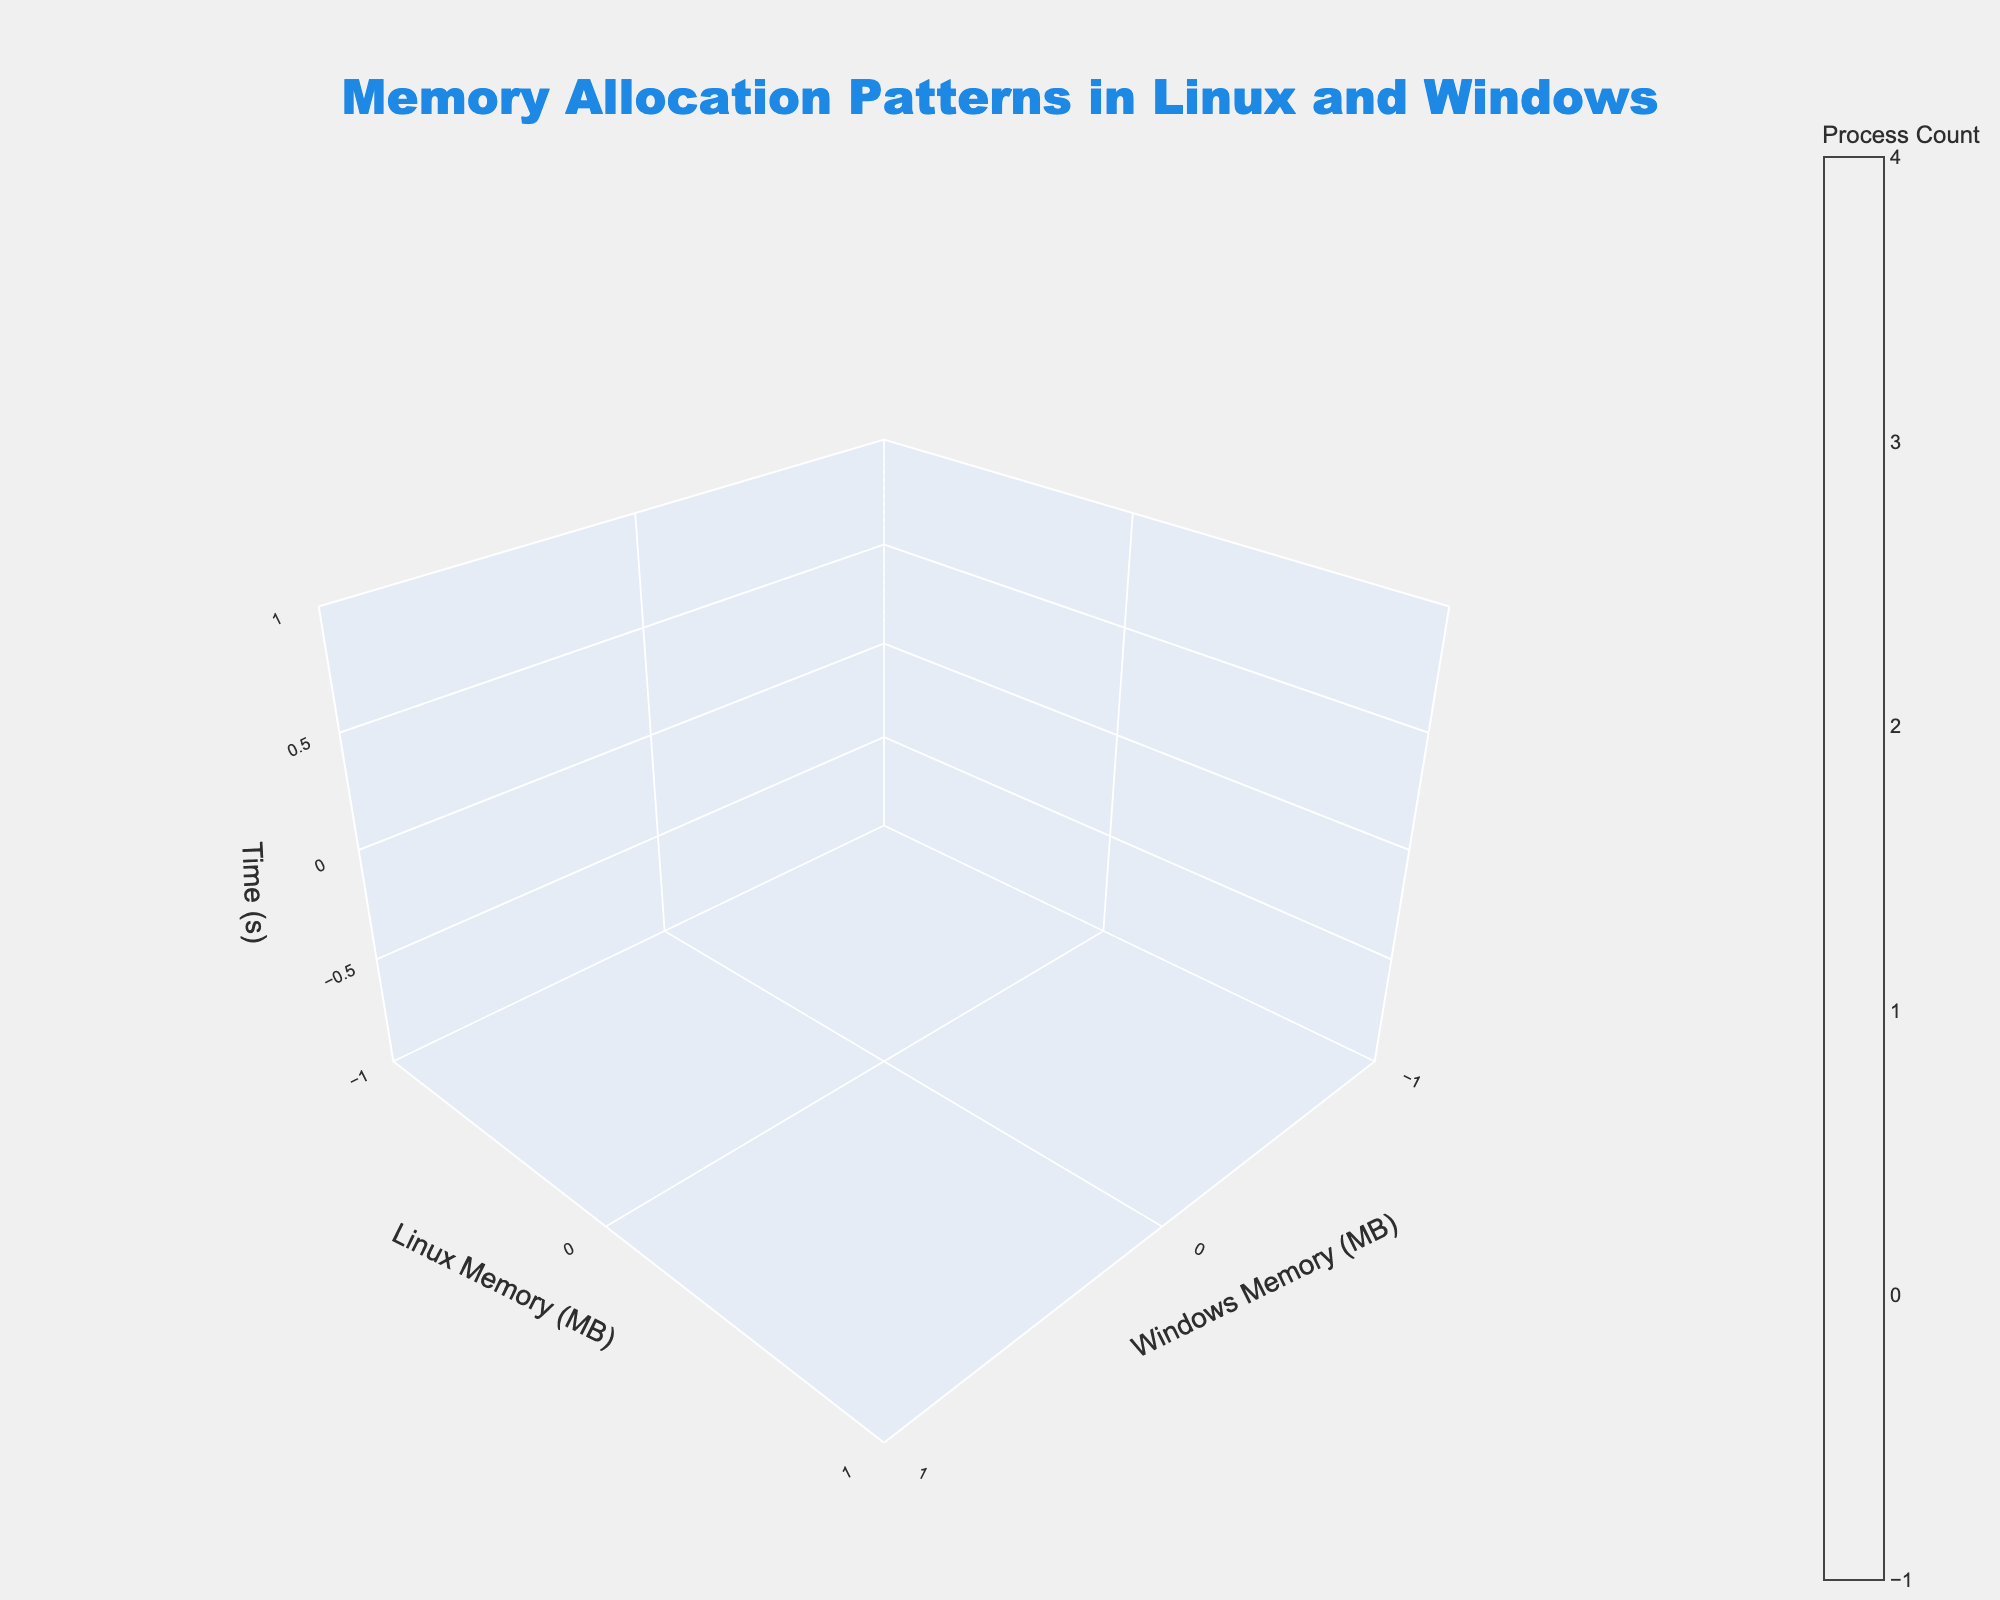What's the title of the 3D volume plot? The title is positioned prominently at the top of the plot.
Answer: Memory Allocation Patterns in Linux and Windows What do the axes represent? The labels on the axes indicate their meaning: the X-axis represents Windows Memory (MB), the Y-axis represents Linux Memory (MB), and the Z-axis represents Time (seconds).
Answer: Windows Memory (MB), Linux Memory (MB), Time (s) How many process counts are represented in the plot at the 0 second mark? By looking at the lowest point in the Z-axis (Time (s) = 0) and mapping to the color scale, we can see the process count value.
Answer: 10 Which memory allocation reaches 2048 MB first, Linux or Windows? Trace both Linux and Windows memory allocations from the plot and see which one reaches 2048 MB first. Windows reaches 2048 MB before Linux.
Answer: Windows What is the difference in memory allocation between Windows and Linux at 30 seconds? Observe the plot at the 30 second mark on the Z-axis. At 30 seconds, Windows memory is at 1536 MB, and Linux memory is at 768 MB. So, the difference is 1536 - 768 = 768 MB.
Answer: 768 MB At 45 seconds, is the Windows memory allocation exactly double that of the Linux memory allocation? Check the plot at 45 seconds. Windows memory is 2304 MB and Linux memory is 1152 MB. Since 2304/1152 = 2, the Windows memory is indeed double.
Answer: Yes What is the average process count at 20 seconds and 40 seconds? Locate these two points on the Z-axis and read the process count values. At 20 seconds it's 100, and at 40 seconds it's 200. The average is (100 + 200) / 2 = 150.
Answer: 150 How does the memory allocation for both systems change over time? Follow the trend of both memory allocations on the X and Y axes. Both increase over time. Windows memory grows steadily faster than Linux memory but both show a linear increase.
Answer: Increases steadily How many surface levels are there in the plot? The color bar on the right and the smooth transitions indicate the number of surface levels. According to the code, there are 20 surface levels.
Answer: 20 Comparing the data points at 60 seconds, by how much does the Windows memory allocation surpass the Linux memory allocation? At 60 seconds, Windows memory is at 3072 MB, and Linux memory is at 1536 MB. 3072 - 1536 = 1536 MB.
Answer: 1536 MB 